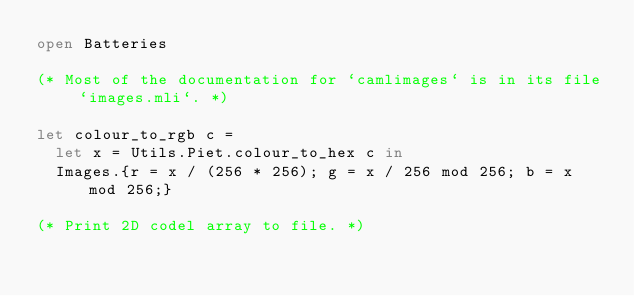Convert code to text. <code><loc_0><loc_0><loc_500><loc_500><_OCaml_>open Batteries

(* Most of the documentation for `camlimages` is in its file `images.mli`. *)

let colour_to_rgb c =
  let x = Utils.Piet.colour_to_hex c in
  Images.{r = x / (256 * 256); g = x / 256 mod 256; b = x mod 256;}

(* Print 2D codel array to file. *)</code> 